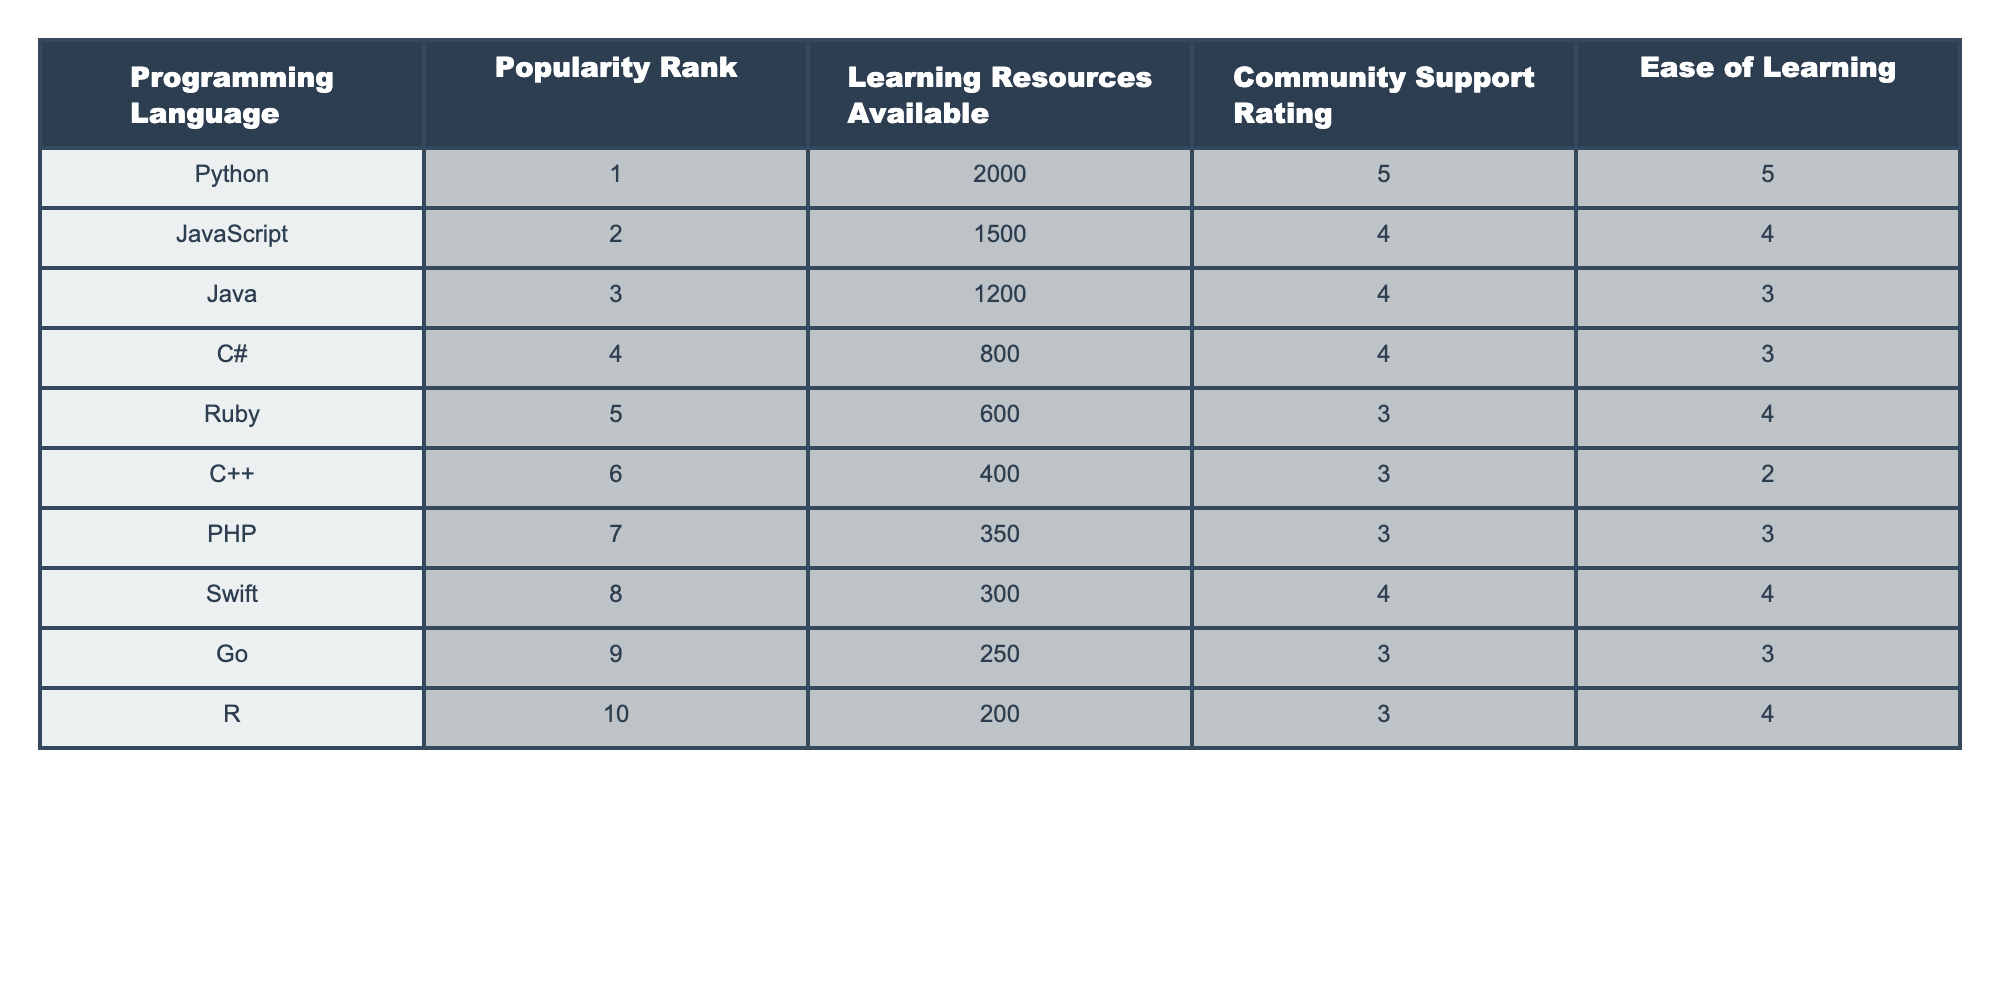What is the popularity rank of Python? Looking at the table, the first column lists the programming languages along with their popularity rank in the second column. Python is in the first row, and its popularity rank is 1.
Answer: 1 Which programming language has the highest community support rating? The community support rating is listed in the fourth column of the table. Scanning through the ratings, Python has the highest rating of 5, which appears at the top.
Answer: Python What is the average ease of learning for the languages listed? To find the average, we sum the ease of learning values for all languages: (5 + 4 + 3 + 3 + 4 + 2 + 3 + 4 + 3 + 4) = 39. There are 10 languages, so the average is 39/10 = 3.9.
Answer: 3.9 Is Ruby ranked higher than C++? Ruby is in the fifth position while C++ is in the sixth position according to the popularity ranks in the second column of the table. Therefore, Ruby is indeed ranked higher than C++.
Answer: Yes How many programming languages have a learning resources availability of less than 500? The third column lists the available learning resources for each language. The languages with less than 500 resources are C++ (400), PHP (350), and Go (250), totaling 3 languages.
Answer: 3 What is the difference in popularity rank between Java and C#? The popularity rank for Java is 3, and for C#, it is 4. The difference is calculated as 4 - 3 = 1.
Answer: 1 Do more programming languages have a community support rating of 4 or higher than those with a rating below 4? The languages with a community support rating of 4 or higher are Python (5), JavaScript (4), C# (4), Swift (4), totaling 4 languages. In contrast, the languages with a rating below 4 are Ruby (3), C++ (3), PHP (3), R (3), totaling 4 languages as well. Therefore, the numbers are equal.
Answer: No Which programming language has the lowest ease of learning? By examining the ease of learning column, the lowest rating is 2, which corresponds to C++. Thus, C++ has the lowest ease of learning score.
Answer: C++ What is the total number of learning resources available for Python and Java combined? The availability of learning resources from the table shows Python has 2000 and Java has 1200. Adding these together gives 2000 + 1200 = 3200.
Answer: 3200 Which programming language has a community support rating of 3, but an ease of learning rating of 4? Only Ruby and PHP both have a community support rating of 3, while the easiest language with a rating of 4 noted in the ease of learning column is Swift. Therefore, none of the languages meet both criteria as per the data in the table.
Answer: None 